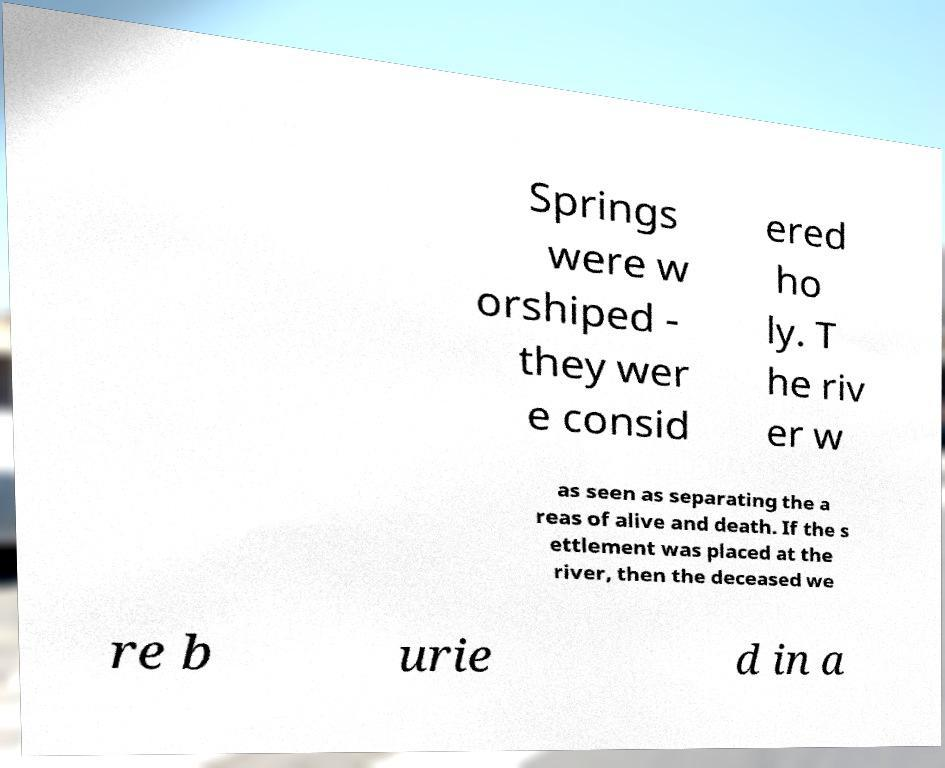There's text embedded in this image that I need extracted. Can you transcribe it verbatim? Springs were w orshiped - they wer e consid ered ho ly. T he riv er w as seen as separating the a reas of alive and death. If the s ettlement was placed at the river, then the deceased we re b urie d in a 